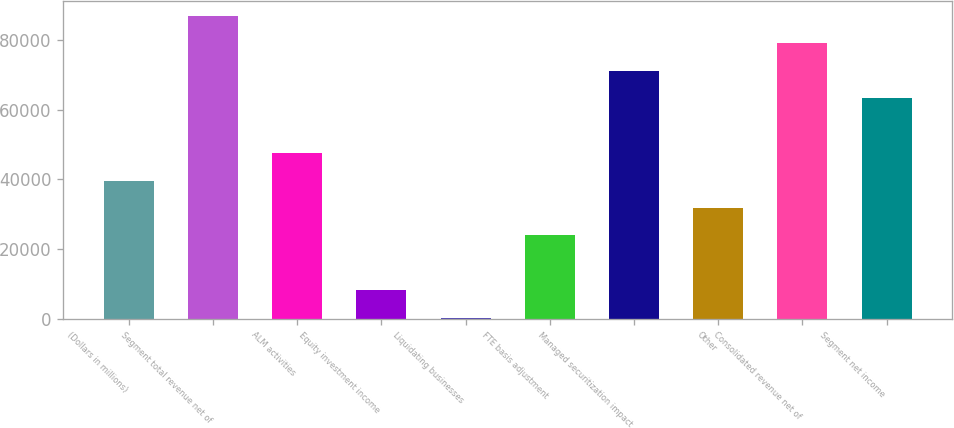Convert chart to OTSL. <chart><loc_0><loc_0><loc_500><loc_500><bar_chart><fcel>(Dollars in millions)<fcel>Segment total revenue net of<fcel>ALM activities<fcel>Equity investment income<fcel>Liquidating businesses<fcel>FTE basis adjustment<fcel>Managed securitization impact<fcel>Other<fcel>Consolidated revenue net of<fcel>Segment net income<nl><fcel>39700<fcel>87032.8<fcel>47588.8<fcel>8144.8<fcel>256<fcel>23922.4<fcel>71255.2<fcel>31811.2<fcel>79144<fcel>63366.4<nl></chart> 